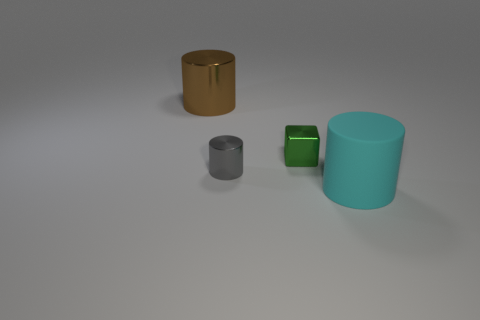Is there any other thing that is made of the same material as the cyan cylinder?
Keep it short and to the point. No. What is the material of the tiny green cube?
Ensure brevity in your answer.  Metal. Is the number of small metal cubes that are to the left of the rubber object greater than the number of large rubber cylinders that are to the left of the brown shiny object?
Provide a succinct answer. Yes. There is a cyan thing that is the same shape as the gray thing; what is its size?
Your answer should be very brief. Large. What number of spheres are either big yellow rubber things or cyan matte objects?
Provide a succinct answer. 0. Are there fewer tiny shiny blocks in front of the big metal object than matte cylinders that are left of the tiny green block?
Keep it short and to the point. No. What number of things are things to the right of the small gray metallic thing or tiny metal things?
Make the answer very short. 3. What shape is the cyan matte thing in front of the small metallic object behind the small cylinder?
Offer a terse response. Cylinder. Are there any objects that have the same size as the gray cylinder?
Keep it short and to the point. Yes. Are there more tiny brown metal things than green objects?
Provide a short and direct response. No. 